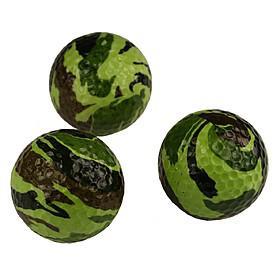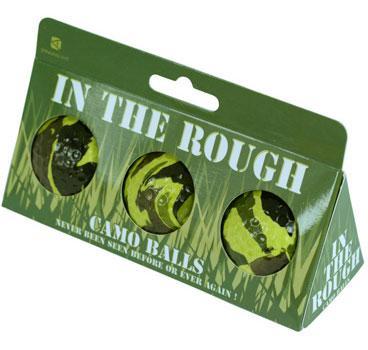The first image is the image on the left, the second image is the image on the right. For the images displayed, is the sentence "The image on the right includes a box of three camo patterned golf balls, and the image on the left includes a group of three balls that are not in a package." factually correct? Answer yes or no. Yes. The first image is the image on the left, the second image is the image on the right. Examine the images to the left and right. Is the description "The left and right image contains the same number of combat golf balls." accurate? Answer yes or no. Yes. 